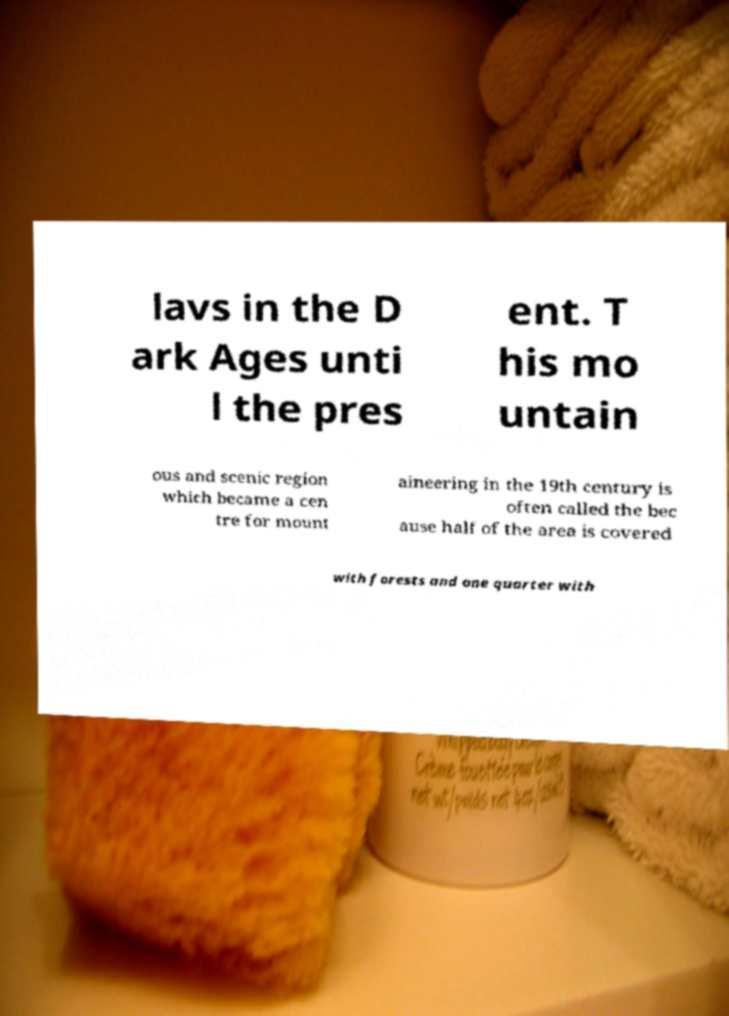Could you extract and type out the text from this image? lavs in the D ark Ages unti l the pres ent. T his mo untain ous and scenic region which became a cen tre for mount aineering in the 19th century is often called the bec ause half of the area is covered with forests and one quarter with 